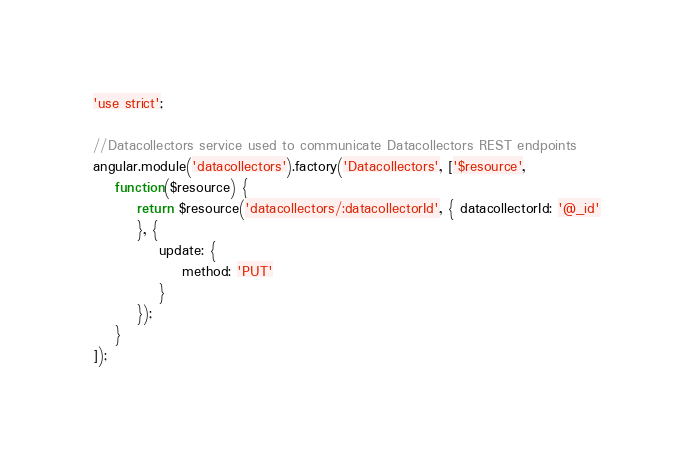Convert code to text. <code><loc_0><loc_0><loc_500><loc_500><_JavaScript_>'use strict';

//Datacollectors service used to communicate Datacollectors REST endpoints
angular.module('datacollectors').factory('Datacollectors', ['$resource',
	function($resource) {
		return $resource('datacollectors/:datacollectorId', { datacollectorId: '@_id'
		}, {
			update: {
				method: 'PUT'
			}
		});
	}
]);</code> 